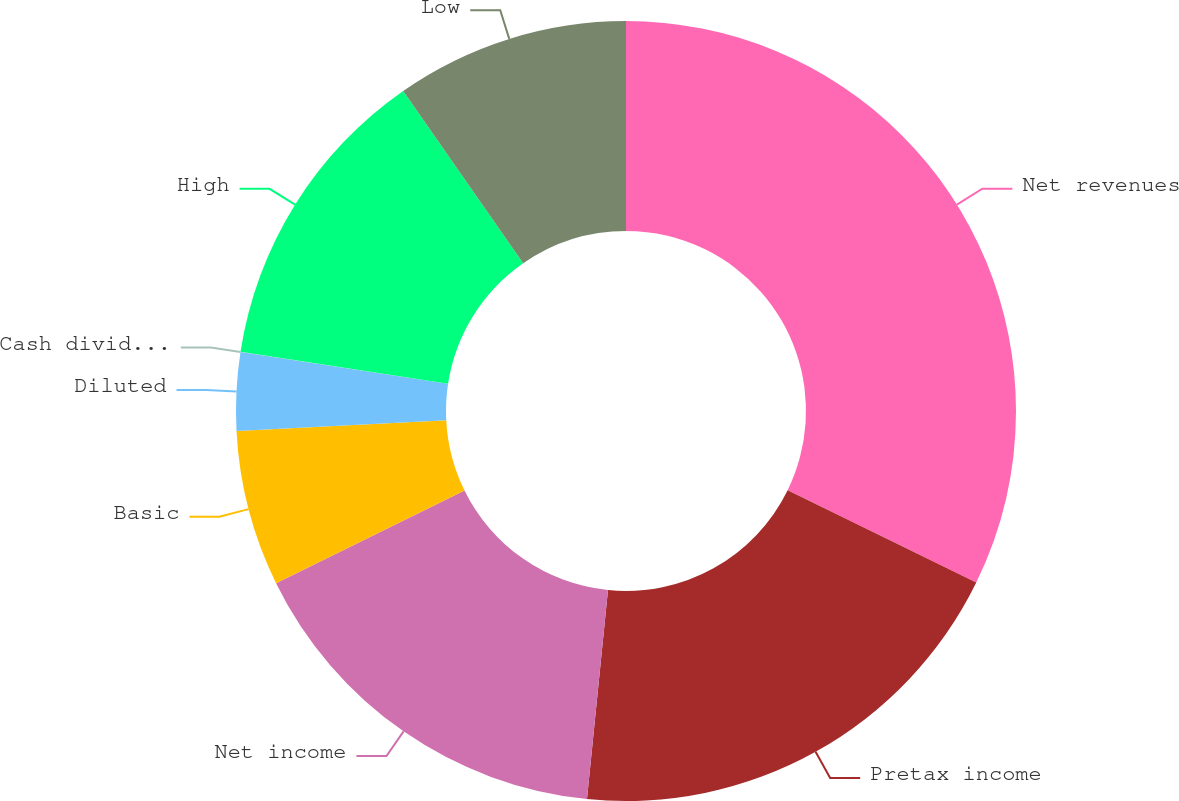<chart> <loc_0><loc_0><loc_500><loc_500><pie_chart><fcel>Net revenues<fcel>Pretax income<fcel>Net income<fcel>Basic<fcel>Diluted<fcel>Cash dividends declared per<fcel>High<fcel>Low<nl><fcel>32.25%<fcel>19.35%<fcel>16.13%<fcel>6.46%<fcel>3.23%<fcel>0.01%<fcel>12.9%<fcel>9.68%<nl></chart> 